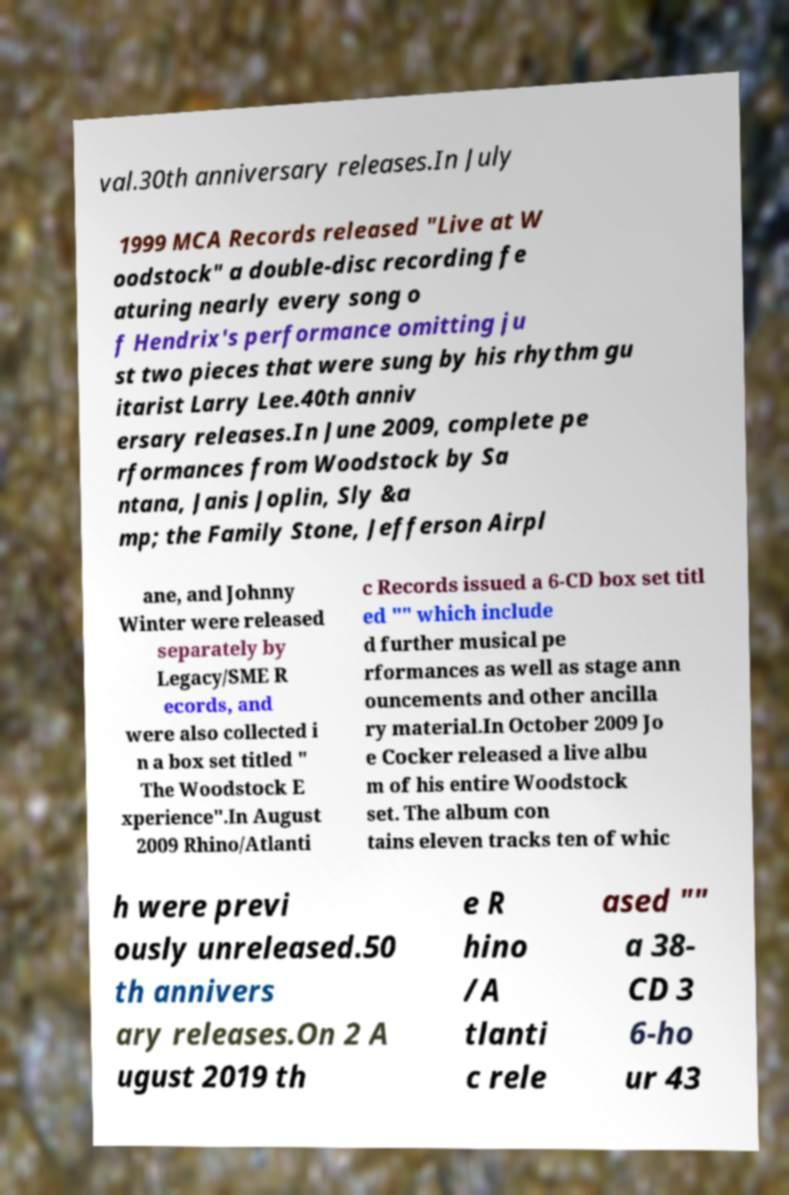Could you extract and type out the text from this image? val.30th anniversary releases.In July 1999 MCA Records released "Live at W oodstock" a double-disc recording fe aturing nearly every song o f Hendrix's performance omitting ju st two pieces that were sung by his rhythm gu itarist Larry Lee.40th anniv ersary releases.In June 2009, complete pe rformances from Woodstock by Sa ntana, Janis Joplin, Sly &a mp; the Family Stone, Jefferson Airpl ane, and Johnny Winter were released separately by Legacy/SME R ecords, and were also collected i n a box set titled " The Woodstock E xperience".In August 2009 Rhino/Atlanti c Records issued a 6-CD box set titl ed "" which include d further musical pe rformances as well as stage ann ouncements and other ancilla ry material.In October 2009 Jo e Cocker released a live albu m of his entire Woodstock set. The album con tains eleven tracks ten of whic h were previ ously unreleased.50 th annivers ary releases.On 2 A ugust 2019 th e R hino /A tlanti c rele ased "" a 38- CD 3 6-ho ur 43 